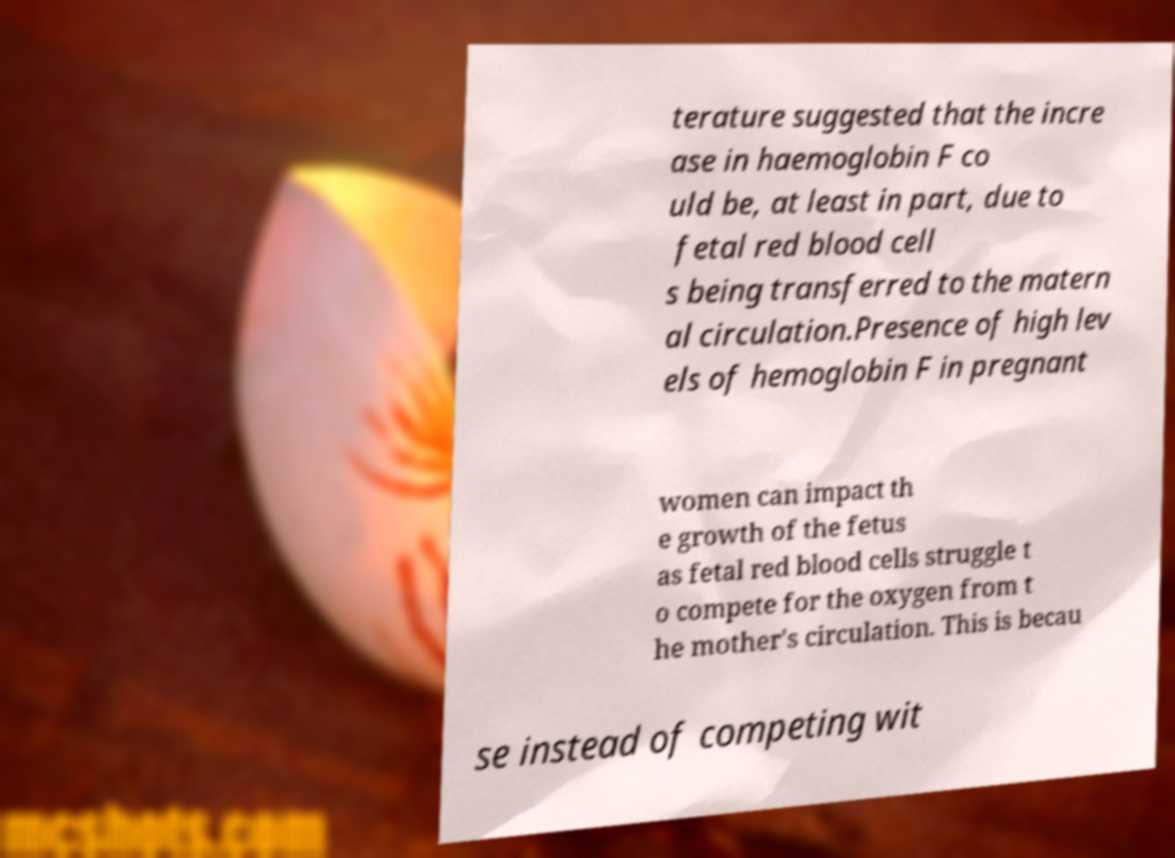For documentation purposes, I need the text within this image transcribed. Could you provide that? terature suggested that the incre ase in haemoglobin F co uld be, at least in part, due to fetal red blood cell s being transferred to the matern al circulation.Presence of high lev els of hemoglobin F in pregnant women can impact th e growth of the fetus as fetal red blood cells struggle t o compete for the oxygen from t he mother's circulation. This is becau se instead of competing wit 